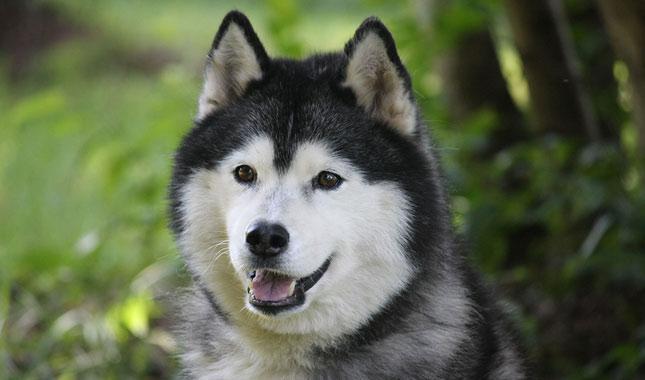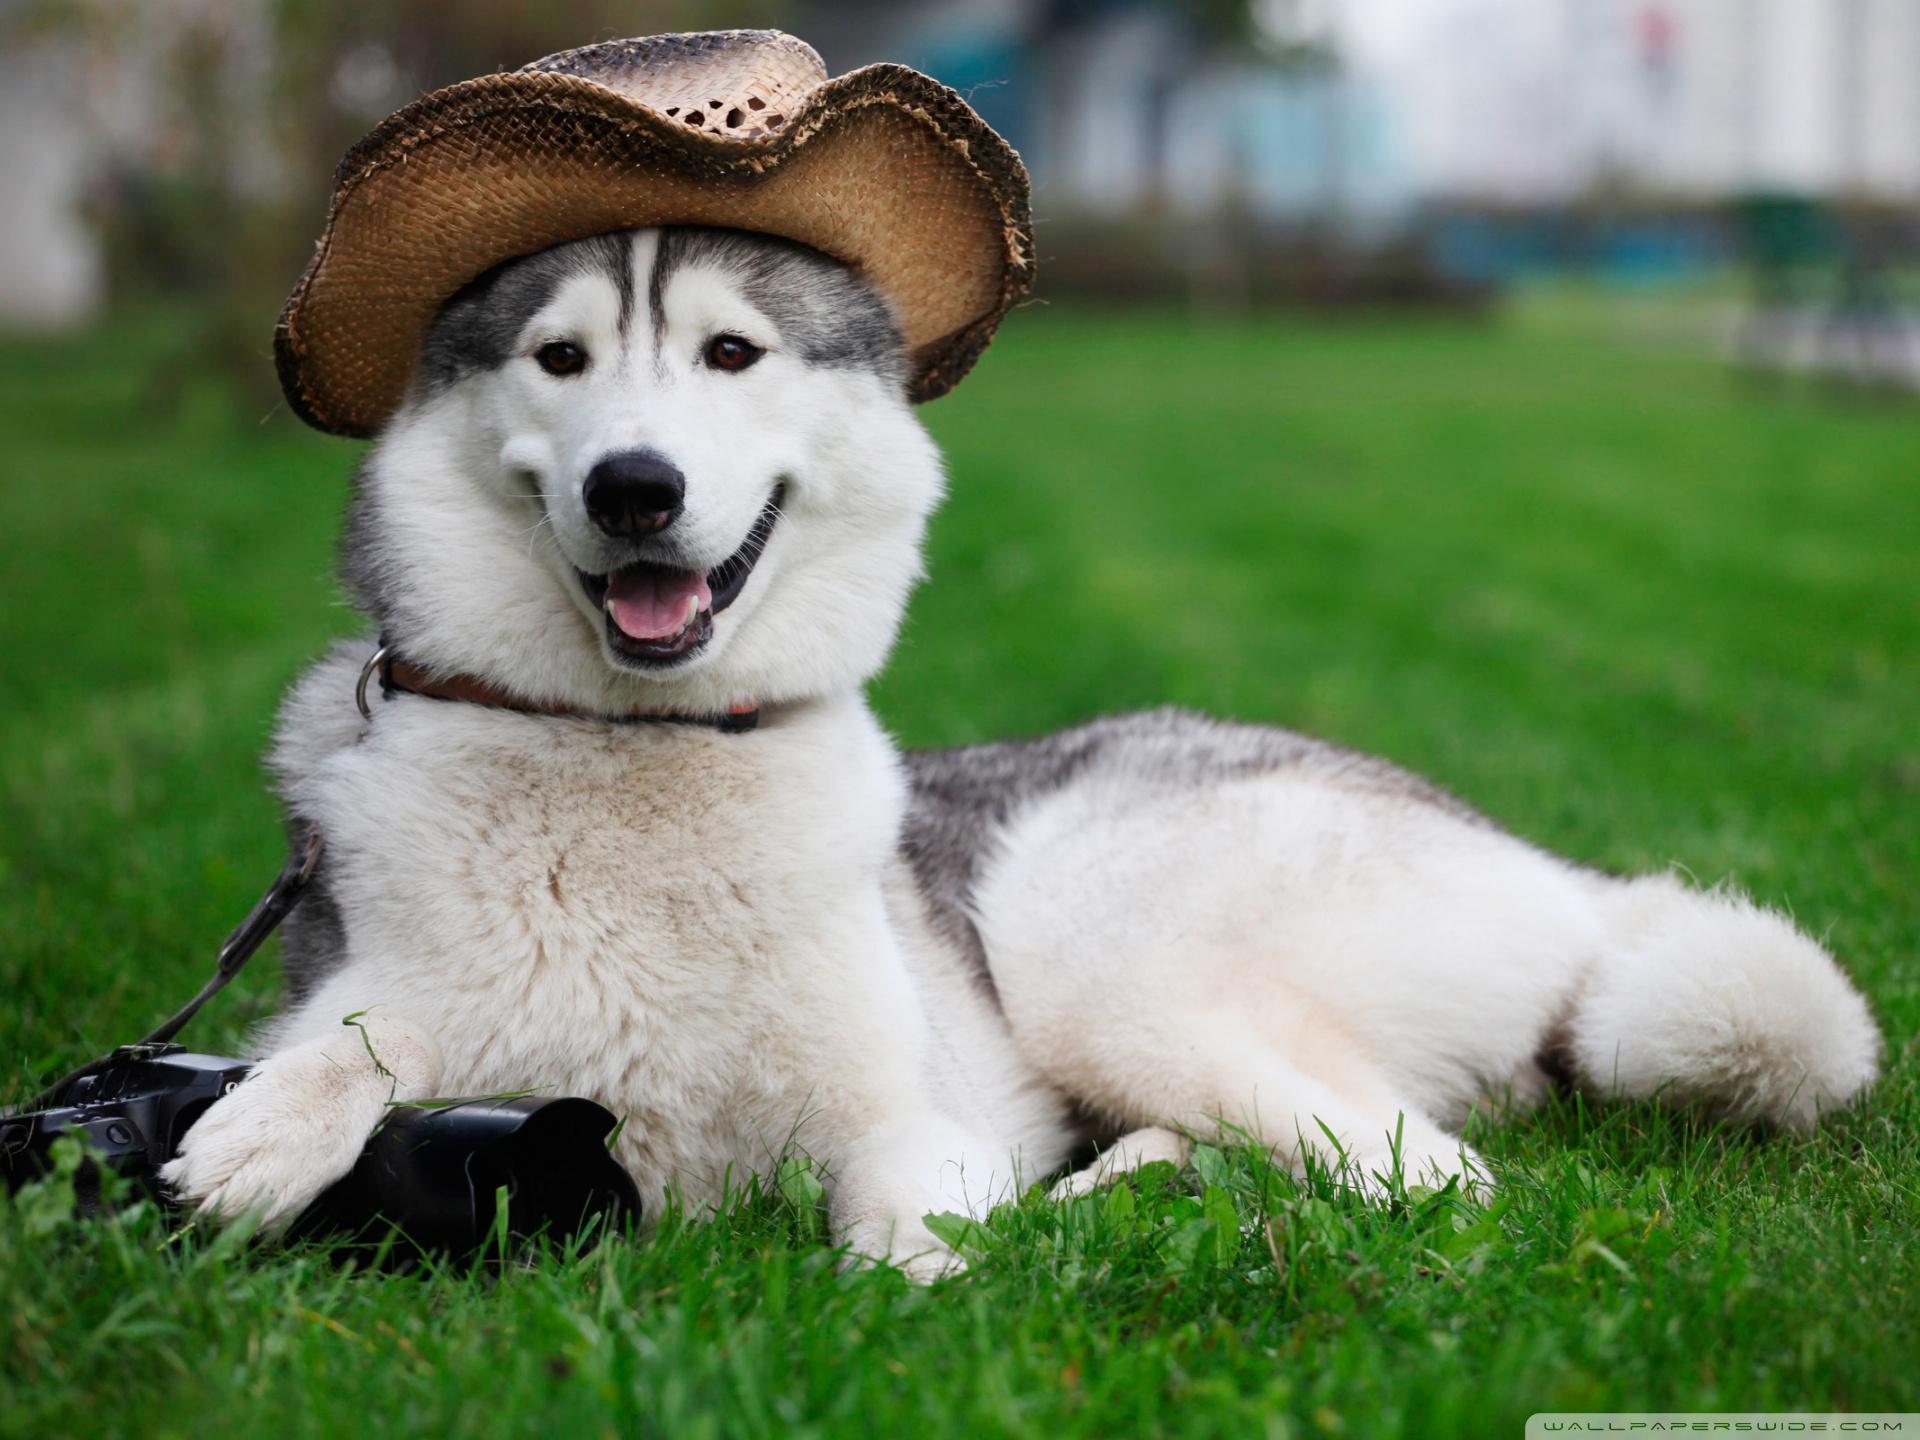The first image is the image on the left, the second image is the image on the right. For the images displayed, is the sentence "There are three Husky dogs." factually correct? Answer yes or no. No. The first image is the image on the left, the second image is the image on the right. For the images displayed, is the sentence "There is a total of three dogs in both images." factually correct? Answer yes or no. No. 